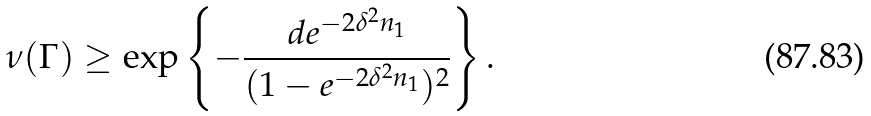Convert formula to latex. <formula><loc_0><loc_0><loc_500><loc_500>\nu ( \Gamma ) \geq \exp \left \{ - \frac { d e ^ { - 2 \delta ^ { 2 } n _ { 1 } } } { ( 1 - e ^ { - 2 \delta ^ { 2 } n _ { 1 } } ) ^ { 2 } } \right \} .</formula> 